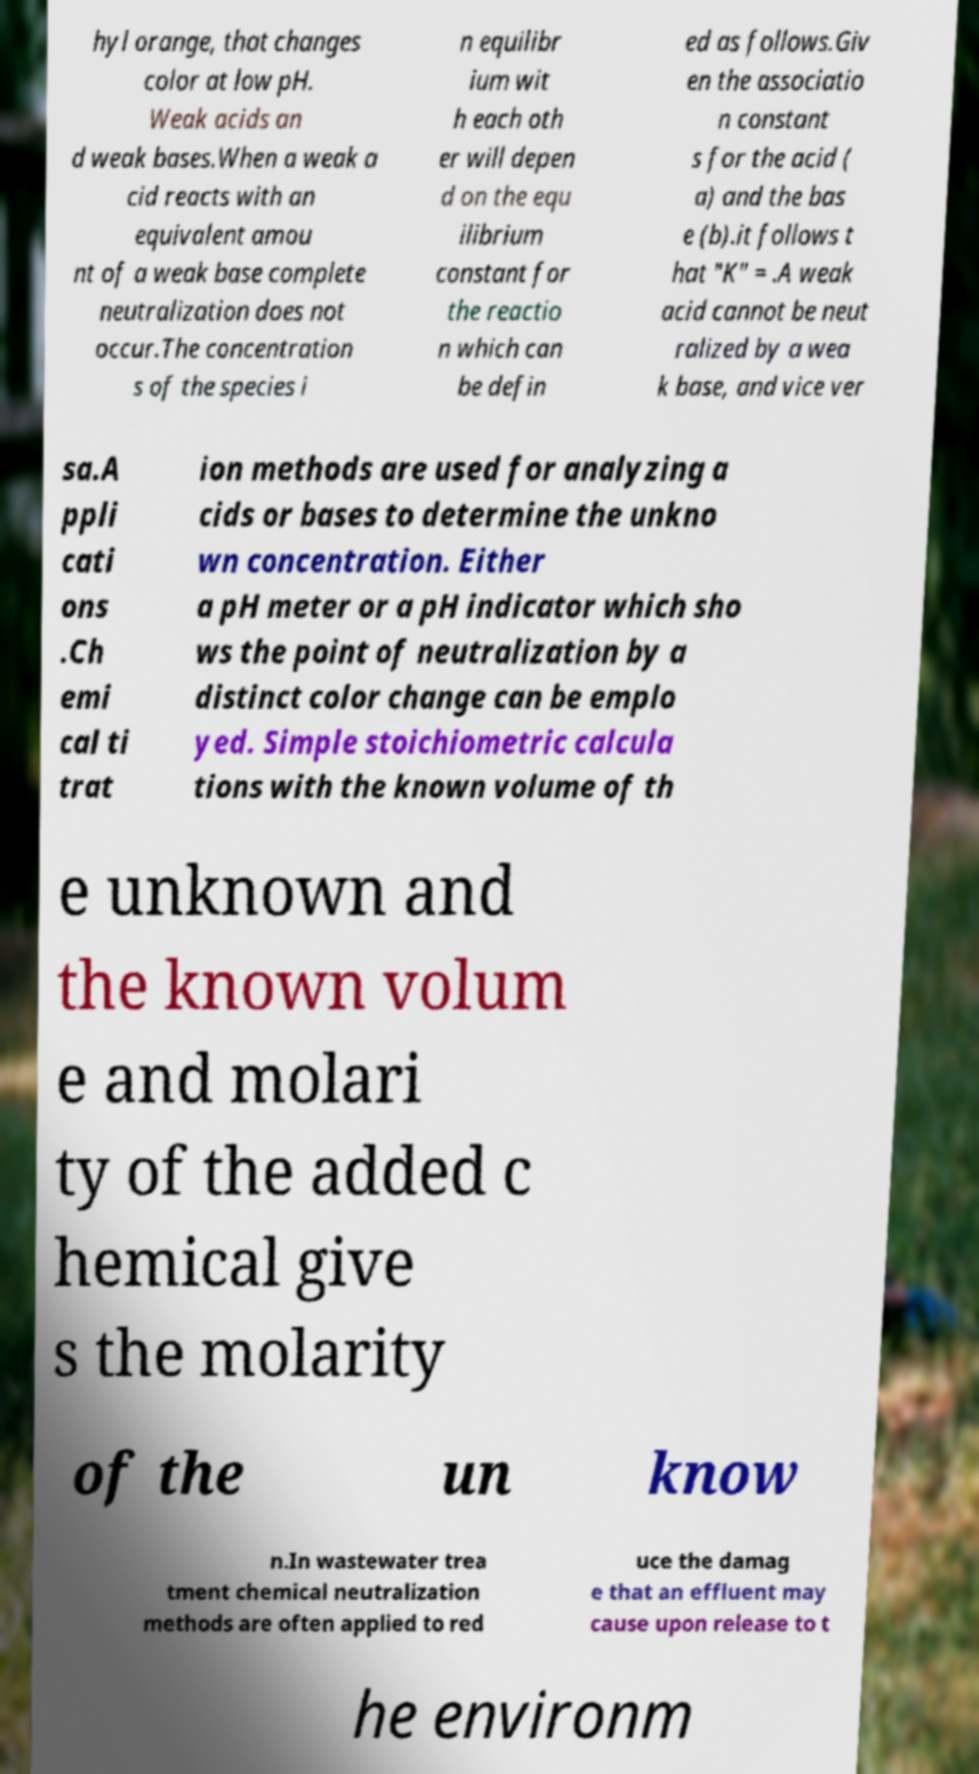Please read and relay the text visible in this image. What does it say? hyl orange, that changes color at low pH. Weak acids an d weak bases.When a weak a cid reacts with an equivalent amou nt of a weak base complete neutralization does not occur.The concentration s of the species i n equilibr ium wit h each oth er will depen d on the equ ilibrium constant for the reactio n which can be defin ed as follows.Giv en the associatio n constant s for the acid ( a) and the bas e (b).it follows t hat "K" = .A weak acid cannot be neut ralized by a wea k base, and vice ver sa.A ppli cati ons .Ch emi cal ti trat ion methods are used for analyzing a cids or bases to determine the unkno wn concentration. Either a pH meter or a pH indicator which sho ws the point of neutralization by a distinct color change can be emplo yed. Simple stoichiometric calcula tions with the known volume of th e unknown and the known volum e and molari ty of the added c hemical give s the molarity of the un know n.In wastewater trea tment chemical neutralization methods are often applied to red uce the damag e that an effluent may cause upon release to t he environm 